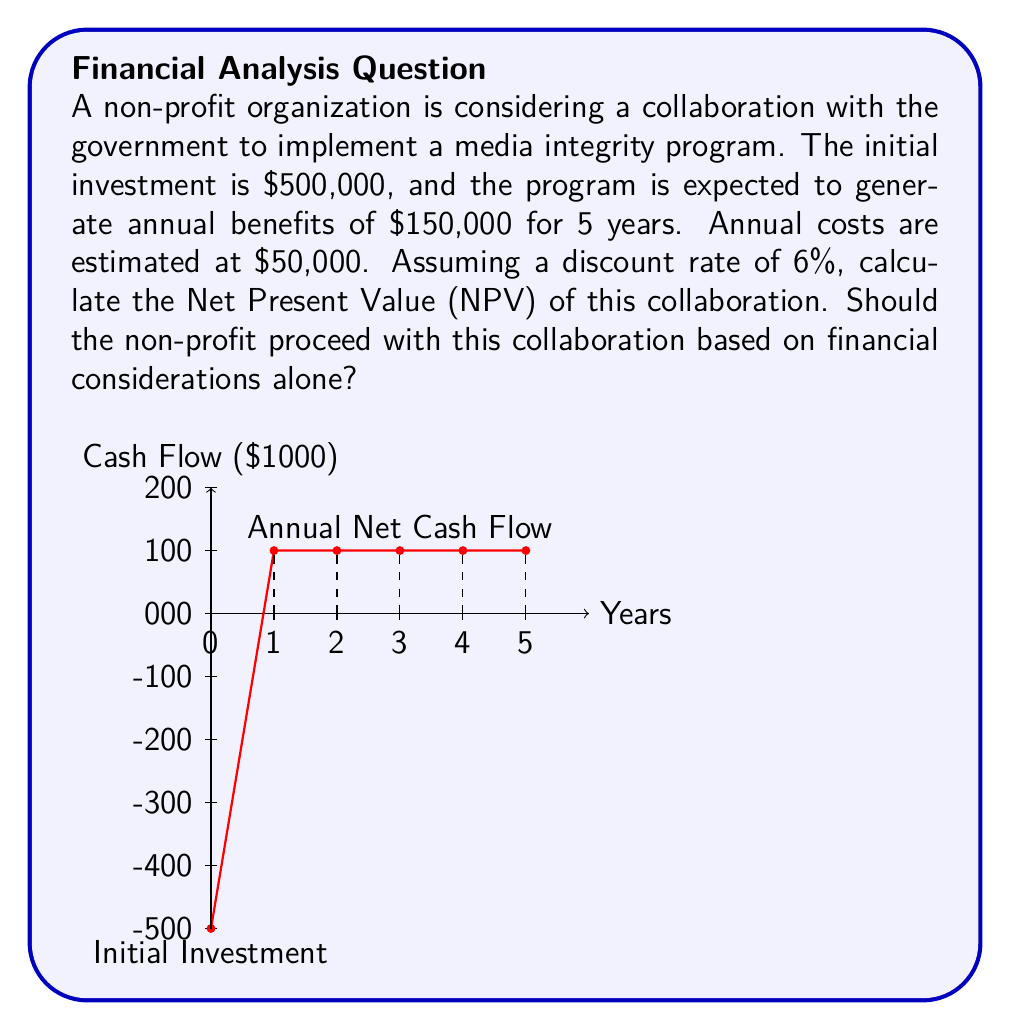Can you solve this math problem? To determine if the non-profit should proceed with the collaboration, we need to calculate the Net Present Value (NPV) of the project. We'll follow these steps:

1) Identify the cash flows:
   Initial investment: -$500,000
   Annual net cash flow: $150,000 - $50,000 = $100,000 for 5 years

2) Calculate the Present Value (PV) of future cash flows:
   Using the NPV formula: $NPV = -C_0 + \sum_{t=1}^{n} \frac{C_t}{(1+r)^t}$
   Where $C_0$ is the initial investment, $C_t$ is the cash flow at time t, r is the discount rate, and n is the number of periods.

3) Calculate the PV of each year's cash flow:
   Year 1: $\frac{100,000}{(1+0.06)^1} = 94,339.62$
   Year 2: $\frac{100,000}{(1+0.06)^2} = 89,000.59$
   Year 3: $\frac{100,000}{(1+0.06)^3} = 83,962.82$
   Year 4: $\frac{100,000}{(1+0.06)^4} = 79,209.26$
   Year 5: $\frac{100,000}{(1+0.06)^5} = 74,725.72$

4) Sum up the PV of all cash flows:
   $NPV = -500,000 + 94,339.62 + 89,000.59 + 83,962.82 + 79,209.26 + 74,725.72$
   $NPV = -78,761.99$

5) Interpret the result:
   The NPV is negative, which means the project would result in a financial loss when considering the time value of money.
Answer: NPV = -$78,761.99. The non-profit should not proceed based solely on financial considerations. 